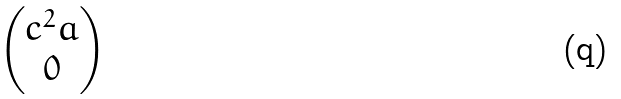<formula> <loc_0><loc_0><loc_500><loc_500>\begin{pmatrix} c ^ { 2 } a \\ 0 \end{pmatrix}</formula> 